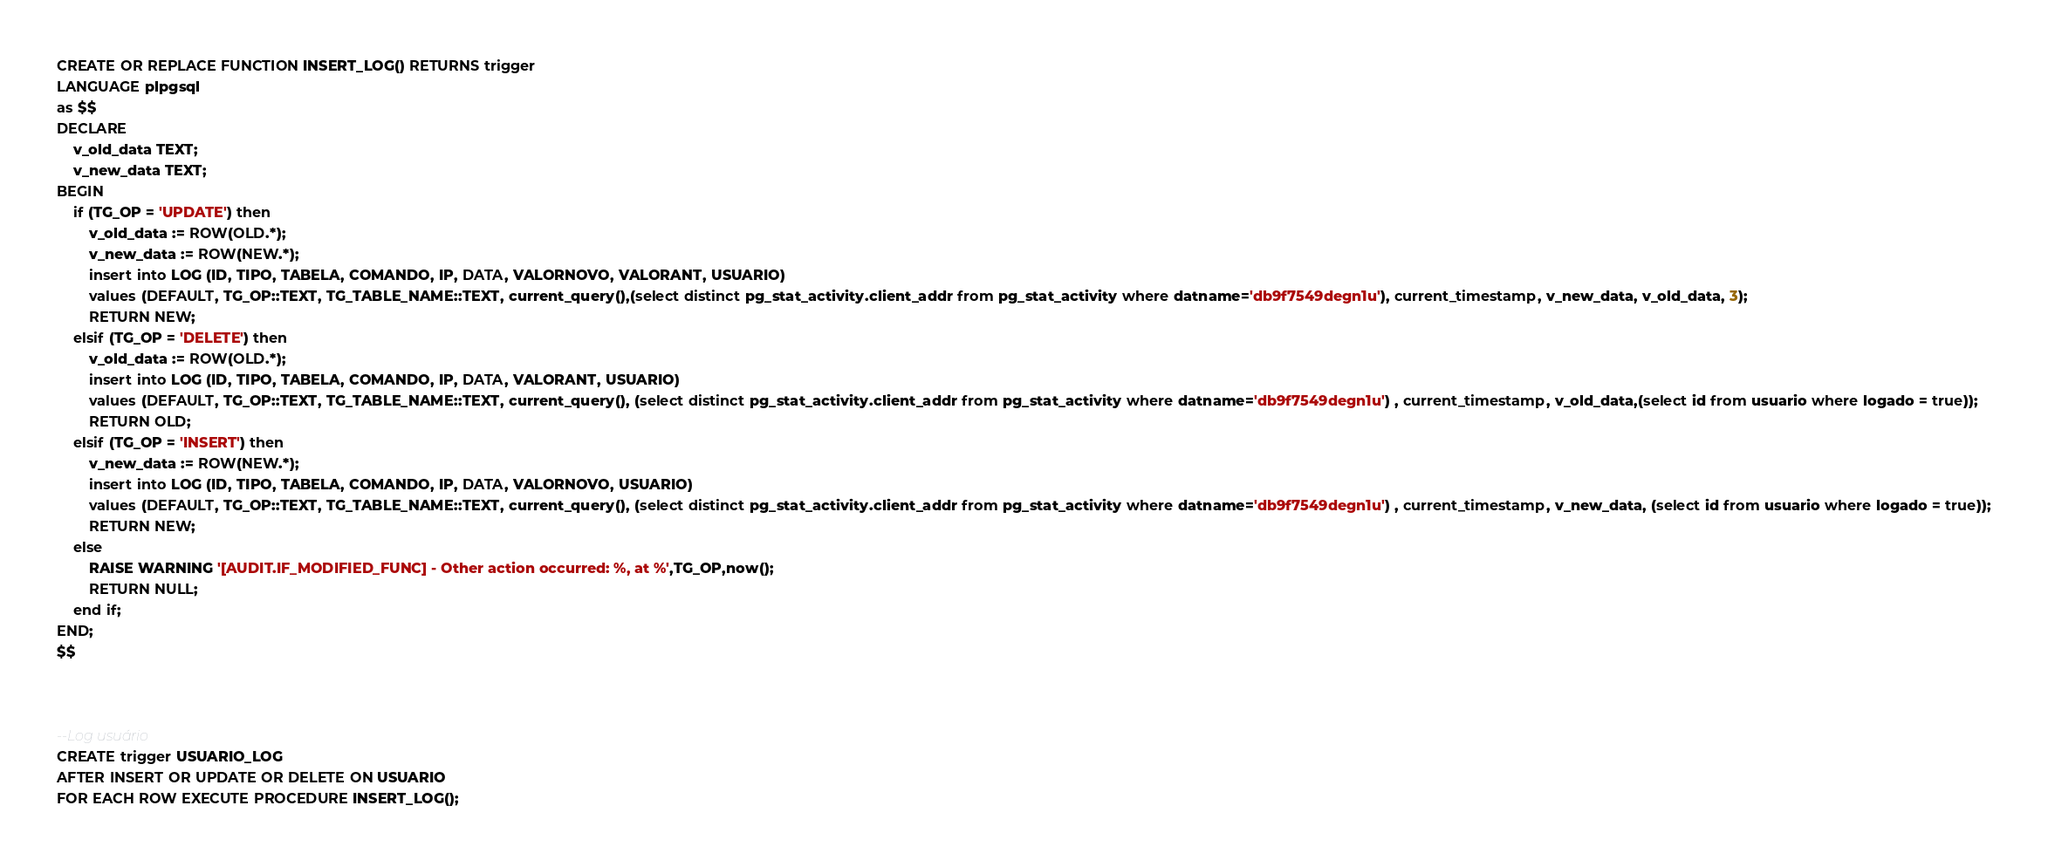Convert code to text. <code><loc_0><loc_0><loc_500><loc_500><_SQL_>CREATE OR REPLACE FUNCTION INSERT_LOG() RETURNS trigger 
LANGUAGE plpgsql
as $$
DECLARE
    v_old_data TEXT;
    v_new_data TEXT;
BEGIN
    if (TG_OP = 'UPDATE') then
        v_old_data := ROW(OLD.*);
        v_new_data := ROW(NEW.*);
        insert into LOG (ID, TIPO, TABELA, COMANDO, IP, DATA, VALORNOVO, VALORANT, USUARIO)   
        values (DEFAULT, TG_OP::TEXT, TG_TABLE_NAME::TEXT, current_query(),(select distinct pg_stat_activity.client_addr from pg_stat_activity where datname='db9f7549degn1u'), current_timestamp, v_new_data, v_old_data, 3);
        RETURN NEW;
    elsif (TG_OP = 'DELETE') then
        v_old_data := ROW(OLD.*);
        insert into LOG (ID, TIPO, TABELA, COMANDO, IP, DATA, VALORANT, USUARIO)  
        values (DEFAULT, TG_OP::TEXT, TG_TABLE_NAME::TEXT, current_query(), (select distinct pg_stat_activity.client_addr from pg_stat_activity where datname='db9f7549degn1u') , current_timestamp, v_old_data,(select id from usuario where logado = true));
        RETURN OLD;
    elsif (TG_OP = 'INSERT') then
        v_new_data := ROW(NEW.*);      
        insert into LOG (ID, TIPO, TABELA, COMANDO, IP, DATA, VALORNOVO, USUARIO)   
        values (DEFAULT, TG_OP::TEXT, TG_TABLE_NAME::TEXT, current_query(), (select distinct pg_stat_activity.client_addr from pg_stat_activity where datname='db9f7549degn1u') , current_timestamp, v_new_data, (select id from usuario where logado = true));
        RETURN NEW;
    else
        RAISE WARNING '[AUDIT.IF_MODIFIED_FUNC] - Other action occurred: %, at %',TG_OP,now();
        RETURN NULL;
    end if;
END;
$$



--Log usuário
CREATE trigger USUARIO_LOG
AFTER INSERT OR UPDATE OR DELETE ON USUARIO
FOR EACH ROW EXECUTE PROCEDURE INSERT_LOG();


</code> 